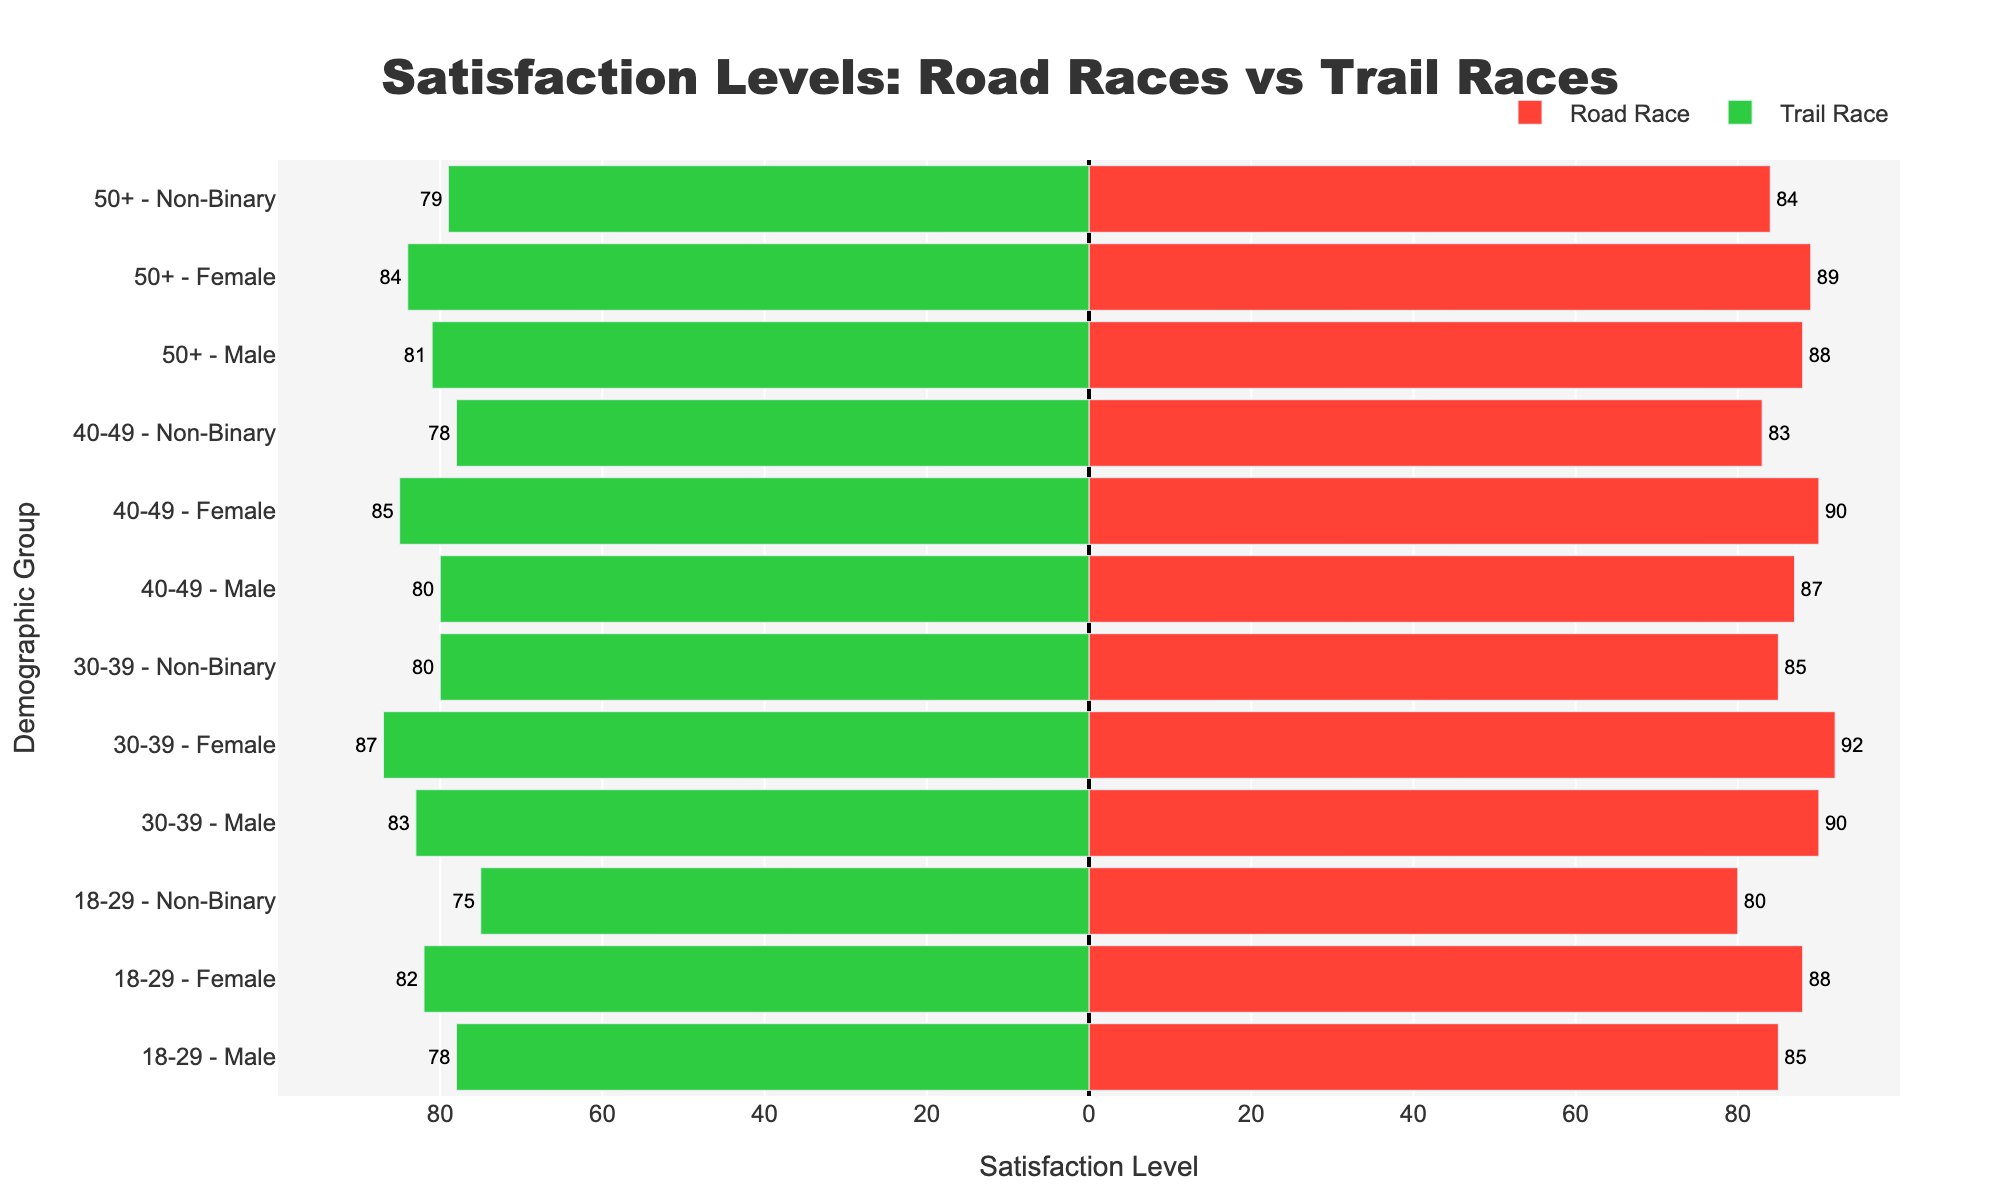Which demographic group has the highest satisfaction level in Road Races? This can be determined by looking for the highest value bar under Road Race. The 30-39 Female group has the highest satisfaction level at 92.
Answer: 30-39 Female Which demographic group has the lowest satisfaction level in Trail Races? By examining the Trail Race bars, the 18-29 Non-Binary group has the lowest satisfaction level at 75.
Answer: 18-29 Non-Binary How much higher is the satisfaction level for 30-39 Male in Road Races compared to Trail Races? Compare the satisfaction levels of 30-39 Male in Road Races (90) and Trail Races (83). The difference is 90 - 83 = 7.
Answer: 7 What is the average satisfaction level for 50+ participants across both Road and Trail Races? Calculate the average by summing the satisfaction levels for 50+ groups in both events and dividing by the number of groups. (88 + 89 + 84 + 81 + 84 + 79) / 6 = (505) / 6 ≈ 84.17.
Answer: 84.17 Does the satisfaction level for Non-Binary participants differ more in the 18-29 or 50+ age group between Road and Trail Races? Compare the differences for Non-Binary participants in 18-29 (80 vs 75 = 5) and 50+ (84 vs 79 = 5). The differences are equal.
Answer: Equal Which gender has the highest satisfaction level in Trail Races for the 40-49 age group? Checking the satisfaction levels for 40-49 in Trail Races, the Female group has the highest satisfaction level at 85.
Answer: Female What is the overall difference in satisfaction levels between 30-39 females in Road Races and Trail Races? Subtract Trail Race satisfaction level from Road Race for 30-39 Females = 92 - 87 = 5.
Answer: 5 For the 18-29 age group, which gender shows a higher satisfaction level in Trail Races, and by how much compared to Road Races? Compare the satisfaction levels: Female in Trail Races (82) is higher than Male (78), and compared to Road Races (88 - 82 = 6).
Answer: Female, 6 What is the combined satisfaction level for Male participants across all age groups in Trail Races? Sum the Trail Race satisfaction levels for Male across all age groups: 78 + 83 + 80 + 81 = 322.
Answer: 322 